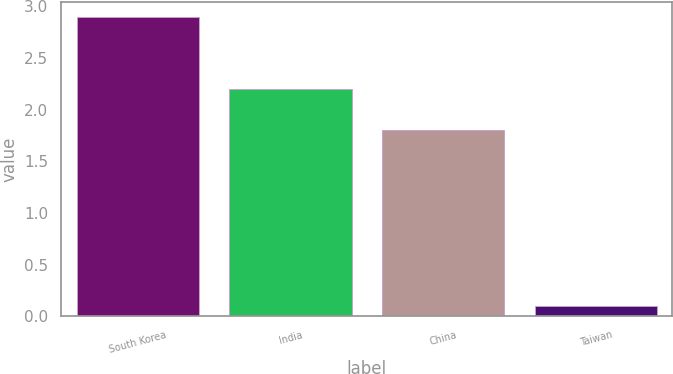<chart> <loc_0><loc_0><loc_500><loc_500><bar_chart><fcel>South Korea<fcel>India<fcel>China<fcel>Taiwan<nl><fcel>2.9<fcel>2.2<fcel>1.8<fcel>0.1<nl></chart> 